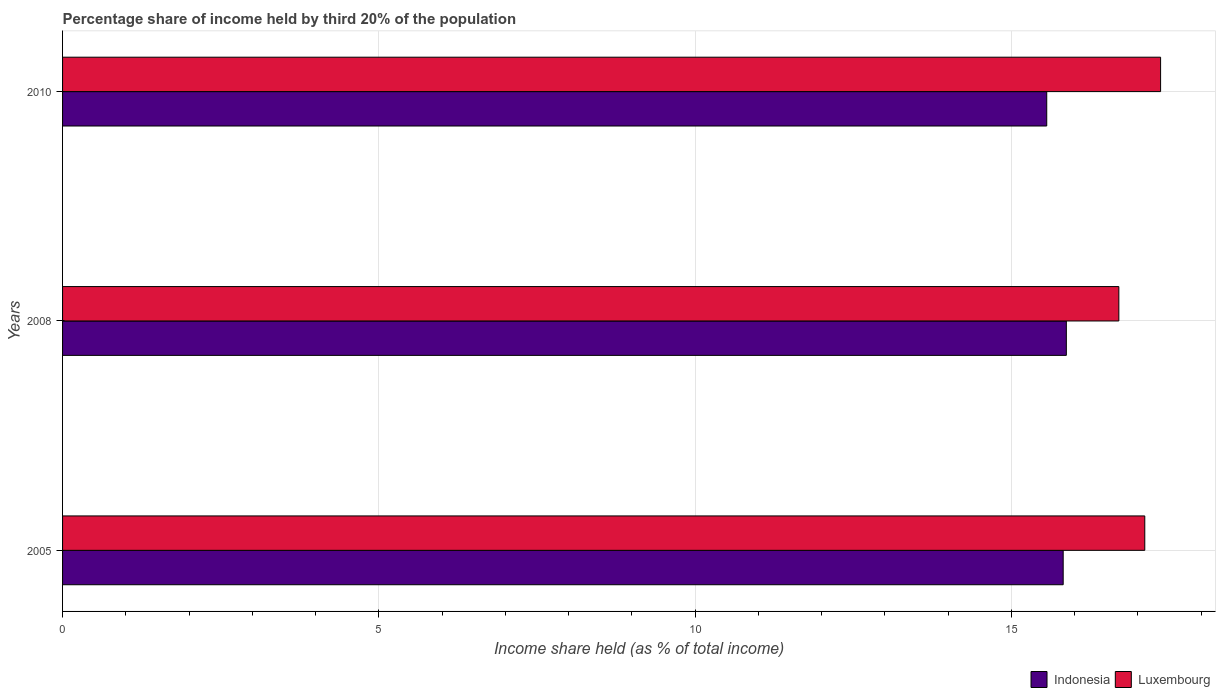Are the number of bars per tick equal to the number of legend labels?
Your response must be concise. Yes. Are the number of bars on each tick of the Y-axis equal?
Your answer should be compact. Yes. What is the share of income held by third 20% of the population in Indonesia in 2005?
Keep it short and to the point. 15.82. Across all years, what is the maximum share of income held by third 20% of the population in Indonesia?
Provide a succinct answer. 15.87. Across all years, what is the minimum share of income held by third 20% of the population in Luxembourg?
Offer a very short reply. 16.7. In which year was the share of income held by third 20% of the population in Luxembourg minimum?
Give a very brief answer. 2008. What is the total share of income held by third 20% of the population in Luxembourg in the graph?
Give a very brief answer. 51.17. What is the difference between the share of income held by third 20% of the population in Luxembourg in 2005 and that in 2010?
Offer a terse response. -0.25. What is the difference between the share of income held by third 20% of the population in Indonesia in 2005 and the share of income held by third 20% of the population in Luxembourg in 2008?
Your answer should be compact. -0.88. What is the average share of income held by third 20% of the population in Indonesia per year?
Offer a terse response. 15.75. In the year 2008, what is the difference between the share of income held by third 20% of the population in Luxembourg and share of income held by third 20% of the population in Indonesia?
Provide a short and direct response. 0.83. What is the ratio of the share of income held by third 20% of the population in Indonesia in 2005 to that in 2010?
Provide a short and direct response. 1.02. Is the share of income held by third 20% of the population in Luxembourg in 2008 less than that in 2010?
Your answer should be very brief. Yes. What is the difference between the highest and the second highest share of income held by third 20% of the population in Indonesia?
Offer a terse response. 0.05. What is the difference between the highest and the lowest share of income held by third 20% of the population in Luxembourg?
Your answer should be compact. 0.66. What does the 2nd bar from the bottom in 2005 represents?
Offer a terse response. Luxembourg. Are all the bars in the graph horizontal?
Provide a succinct answer. Yes. What is the difference between two consecutive major ticks on the X-axis?
Provide a succinct answer. 5. Are the values on the major ticks of X-axis written in scientific E-notation?
Provide a short and direct response. No. Does the graph contain grids?
Keep it short and to the point. Yes. Where does the legend appear in the graph?
Keep it short and to the point. Bottom right. How many legend labels are there?
Provide a short and direct response. 2. How are the legend labels stacked?
Offer a terse response. Horizontal. What is the title of the graph?
Provide a succinct answer. Percentage share of income held by third 20% of the population. What is the label or title of the X-axis?
Your answer should be compact. Income share held (as % of total income). What is the Income share held (as % of total income) in Indonesia in 2005?
Offer a very short reply. 15.82. What is the Income share held (as % of total income) of Luxembourg in 2005?
Keep it short and to the point. 17.11. What is the Income share held (as % of total income) in Indonesia in 2008?
Offer a terse response. 15.87. What is the Income share held (as % of total income) of Indonesia in 2010?
Ensure brevity in your answer.  15.56. What is the Income share held (as % of total income) in Luxembourg in 2010?
Offer a very short reply. 17.36. Across all years, what is the maximum Income share held (as % of total income) in Indonesia?
Provide a short and direct response. 15.87. Across all years, what is the maximum Income share held (as % of total income) of Luxembourg?
Offer a very short reply. 17.36. Across all years, what is the minimum Income share held (as % of total income) of Indonesia?
Your response must be concise. 15.56. Across all years, what is the minimum Income share held (as % of total income) in Luxembourg?
Offer a terse response. 16.7. What is the total Income share held (as % of total income) of Indonesia in the graph?
Offer a terse response. 47.25. What is the total Income share held (as % of total income) of Luxembourg in the graph?
Your response must be concise. 51.17. What is the difference between the Income share held (as % of total income) in Indonesia in 2005 and that in 2008?
Keep it short and to the point. -0.05. What is the difference between the Income share held (as % of total income) in Luxembourg in 2005 and that in 2008?
Your answer should be compact. 0.41. What is the difference between the Income share held (as % of total income) in Indonesia in 2005 and that in 2010?
Your answer should be compact. 0.26. What is the difference between the Income share held (as % of total income) of Luxembourg in 2005 and that in 2010?
Give a very brief answer. -0.25. What is the difference between the Income share held (as % of total income) of Indonesia in 2008 and that in 2010?
Offer a terse response. 0.31. What is the difference between the Income share held (as % of total income) of Luxembourg in 2008 and that in 2010?
Provide a succinct answer. -0.66. What is the difference between the Income share held (as % of total income) in Indonesia in 2005 and the Income share held (as % of total income) in Luxembourg in 2008?
Your answer should be very brief. -0.88. What is the difference between the Income share held (as % of total income) of Indonesia in 2005 and the Income share held (as % of total income) of Luxembourg in 2010?
Provide a short and direct response. -1.54. What is the difference between the Income share held (as % of total income) in Indonesia in 2008 and the Income share held (as % of total income) in Luxembourg in 2010?
Your answer should be very brief. -1.49. What is the average Income share held (as % of total income) of Indonesia per year?
Ensure brevity in your answer.  15.75. What is the average Income share held (as % of total income) in Luxembourg per year?
Ensure brevity in your answer.  17.06. In the year 2005, what is the difference between the Income share held (as % of total income) in Indonesia and Income share held (as % of total income) in Luxembourg?
Make the answer very short. -1.29. In the year 2008, what is the difference between the Income share held (as % of total income) in Indonesia and Income share held (as % of total income) in Luxembourg?
Give a very brief answer. -0.83. What is the ratio of the Income share held (as % of total income) of Luxembourg in 2005 to that in 2008?
Provide a short and direct response. 1.02. What is the ratio of the Income share held (as % of total income) of Indonesia in 2005 to that in 2010?
Provide a short and direct response. 1.02. What is the ratio of the Income share held (as % of total income) in Luxembourg in 2005 to that in 2010?
Provide a succinct answer. 0.99. What is the ratio of the Income share held (as % of total income) of Indonesia in 2008 to that in 2010?
Your answer should be very brief. 1.02. What is the ratio of the Income share held (as % of total income) of Luxembourg in 2008 to that in 2010?
Give a very brief answer. 0.96. What is the difference between the highest and the second highest Income share held (as % of total income) of Indonesia?
Make the answer very short. 0.05. What is the difference between the highest and the second highest Income share held (as % of total income) of Luxembourg?
Offer a very short reply. 0.25. What is the difference between the highest and the lowest Income share held (as % of total income) of Indonesia?
Your answer should be compact. 0.31. What is the difference between the highest and the lowest Income share held (as % of total income) of Luxembourg?
Provide a succinct answer. 0.66. 